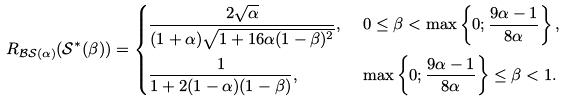Convert formula to latex. <formula><loc_0><loc_0><loc_500><loc_500>R _ { \mathcal { B S } ( \alpha ) } ( \mathcal { S ^ { * } ( \beta ) } ) & = \begin{dcases} \frac { 2 \sqrt { \alpha } } { ( 1 + \alpha ) \sqrt { 1 + 1 6 \alpha ( 1 - \beta ) ^ { 2 } } } , & \ 0 \leq \beta < \max \left \{ 0 ; \frac { 9 \alpha - 1 } { 8 \alpha } \right \} , \\ \frac { 1 } { 1 + 2 ( 1 - \alpha ) ( 1 - \beta ) } , & \ \max \left \{ 0 ; \frac { 9 \alpha - 1 } { 8 \alpha } \right \} \leq \beta < 1 . \end{dcases}</formula> 